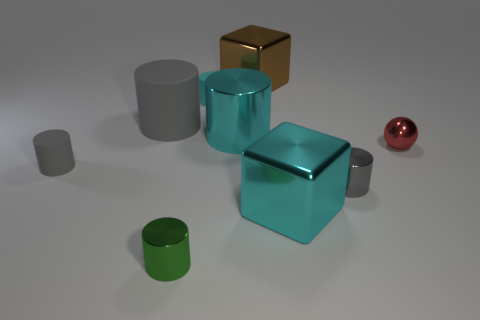What is the shape of the green shiny object?
Give a very brief answer. Cylinder. What shape is the cyan object that is made of the same material as the large gray cylinder?
Offer a terse response. Cylinder. How many other objects are there of the same shape as the big gray rubber object?
Provide a short and direct response. 5. There is a gray thing that is on the right side of the green metallic cylinder; is its size the same as the brown metal object?
Keep it short and to the point. No. Are there more objects to the right of the gray metallic cylinder than large brown rubber things?
Offer a very short reply. Yes. How many metallic objects are on the left side of the rubber cylinder in front of the large gray matte cylinder?
Ensure brevity in your answer.  0. Is the number of large metal objects in front of the shiny sphere less than the number of big brown blocks?
Provide a short and direct response. No. There is a big cyan metal object to the left of the metal block in front of the cyan matte thing; are there any small cyan matte things on the left side of it?
Give a very brief answer. Yes. Does the red object have the same material as the large gray object that is left of the red thing?
Provide a short and direct response. No. What color is the large cylinder in front of the big cylinder left of the small green shiny cylinder?
Provide a succinct answer. Cyan. 